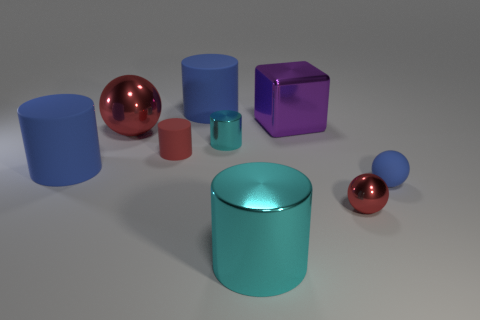Does the small rubber cylinder have the same color as the big sphere?
Make the answer very short. Yes. There is a small blue object; are there any rubber balls in front of it?
Offer a terse response. No. Do the small red ball and the small blue thing have the same material?
Provide a short and direct response. No. What is the color of the big shiny object that is the same shape as the small cyan metal object?
Provide a short and direct response. Cyan. There is a tiny matte object that is behind the small blue thing; does it have the same color as the small metallic ball?
Provide a short and direct response. Yes. The tiny matte thing that is the same color as the large metallic ball is what shape?
Ensure brevity in your answer.  Cylinder. How many cyan cylinders are made of the same material as the big red ball?
Make the answer very short. 2. There is a tiny cyan object; how many small cyan things are in front of it?
Make the answer very short. 0. The purple cube has what size?
Your response must be concise. Large. The sphere that is the same size as the purple metallic cube is what color?
Keep it short and to the point. Red. 